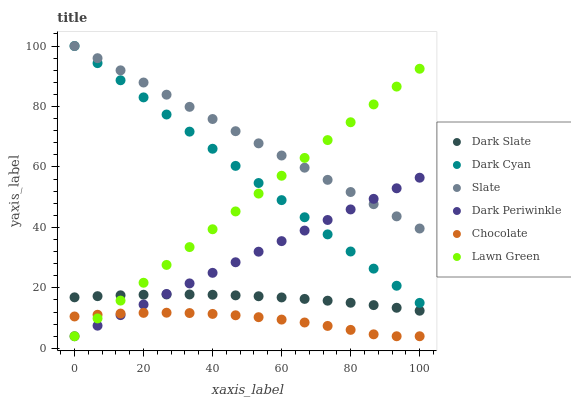Does Chocolate have the minimum area under the curve?
Answer yes or no. Yes. Does Slate have the maximum area under the curve?
Answer yes or no. Yes. Does Slate have the minimum area under the curve?
Answer yes or no. No. Does Chocolate have the maximum area under the curve?
Answer yes or no. No. Is Lawn Green the smoothest?
Answer yes or no. Yes. Is Chocolate the roughest?
Answer yes or no. Yes. Is Slate the smoothest?
Answer yes or no. No. Is Slate the roughest?
Answer yes or no. No. Does Lawn Green have the lowest value?
Answer yes or no. Yes. Does Slate have the lowest value?
Answer yes or no. No. Does Dark Cyan have the highest value?
Answer yes or no. Yes. Does Chocolate have the highest value?
Answer yes or no. No. Is Dark Slate less than Dark Cyan?
Answer yes or no. Yes. Is Slate greater than Chocolate?
Answer yes or no. Yes. Does Lawn Green intersect Dark Slate?
Answer yes or no. Yes. Is Lawn Green less than Dark Slate?
Answer yes or no. No. Is Lawn Green greater than Dark Slate?
Answer yes or no. No. Does Dark Slate intersect Dark Cyan?
Answer yes or no. No. 